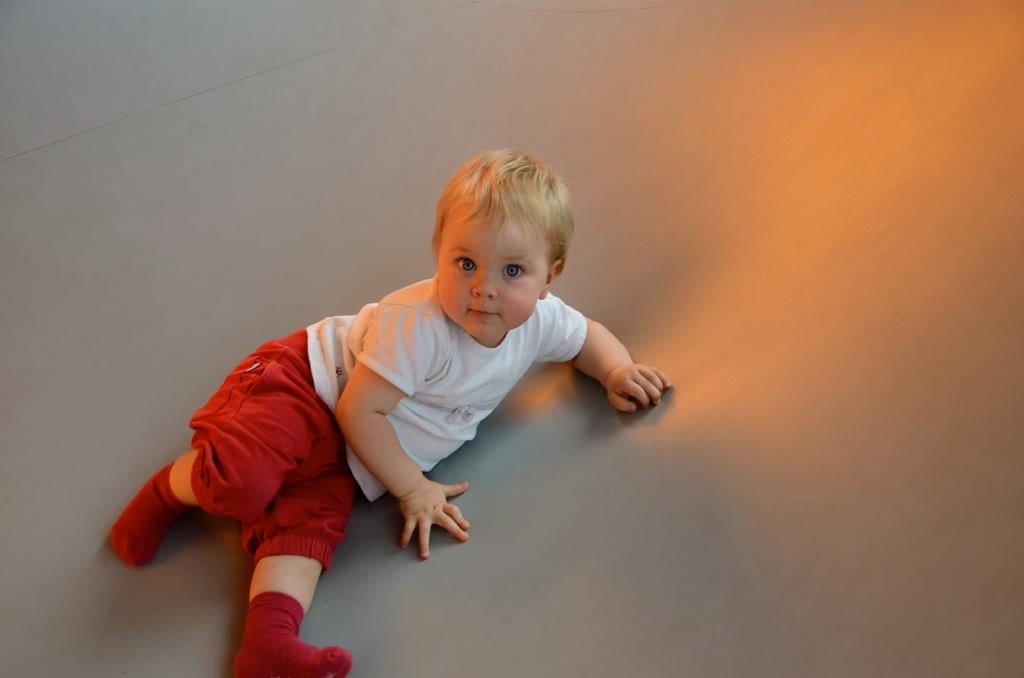What is the main subject of the image? The main subject of the image is a kid. What is the kid wearing in the image? The kid is wearing a white and red dress in the image. What is the kid's position in the image? The kid is lying on a surface in the image. What type of volcano can be seen erupting in the background of the image? There is no volcano present in the image; it features a kid lying on a surface while wearing a white and red dress. 